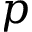Convert formula to latex. <formula><loc_0><loc_0><loc_500><loc_500>p</formula> 